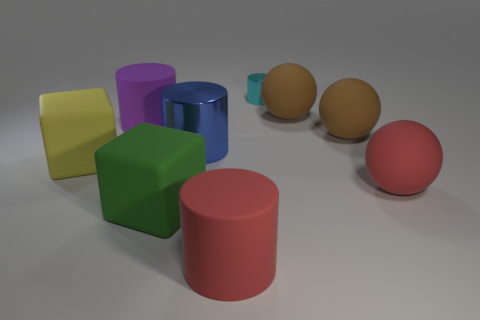Do the cylinder on the right side of the large red rubber cylinder and the block that is to the right of the large purple rubber object have the same material?
Make the answer very short. No. How many objects are either big brown objects or objects that are in front of the small cyan cylinder?
Give a very brief answer. 8. What material is the big yellow cube?
Give a very brief answer. Rubber. Are the red sphere and the purple thing made of the same material?
Provide a succinct answer. Yes. How many matte objects are either large red cylinders or tiny things?
Make the answer very short. 1. The red thing that is behind the big green matte block has what shape?
Provide a succinct answer. Sphere. What size is the blue cylinder that is made of the same material as the cyan cylinder?
Provide a short and direct response. Large. The thing that is both on the left side of the tiny cylinder and right of the blue thing has what shape?
Ensure brevity in your answer.  Cylinder. Is the shape of the shiny object on the left side of the small metallic thing the same as the large red object in front of the large green matte block?
Your answer should be very brief. Yes. What size is the metal thing in front of the small cyan metal cylinder?
Ensure brevity in your answer.  Large. 